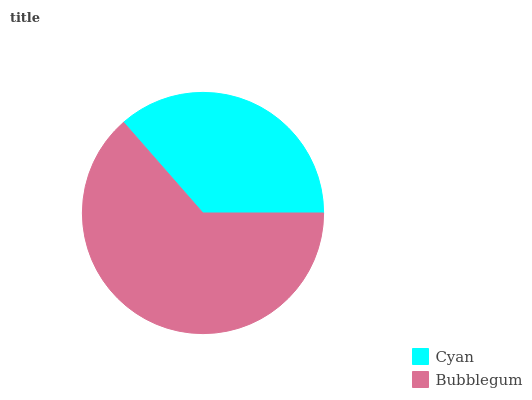Is Cyan the minimum?
Answer yes or no. Yes. Is Bubblegum the maximum?
Answer yes or no. Yes. Is Bubblegum the minimum?
Answer yes or no. No. Is Bubblegum greater than Cyan?
Answer yes or no. Yes. Is Cyan less than Bubblegum?
Answer yes or no. Yes. Is Cyan greater than Bubblegum?
Answer yes or no. No. Is Bubblegum less than Cyan?
Answer yes or no. No. Is Bubblegum the high median?
Answer yes or no. Yes. Is Cyan the low median?
Answer yes or no. Yes. Is Cyan the high median?
Answer yes or no. No. Is Bubblegum the low median?
Answer yes or no. No. 